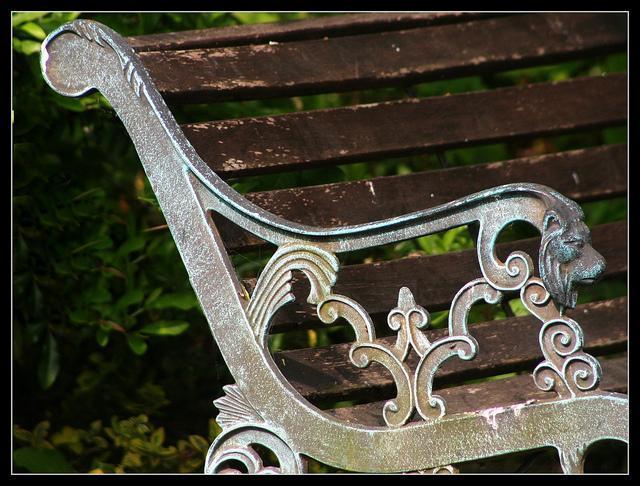How many benches can be seen?
Give a very brief answer. 1. 